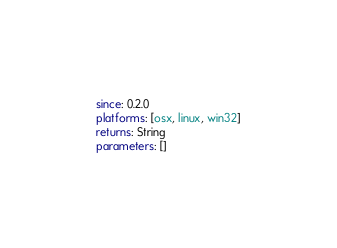<code> <loc_0><loc_0><loc_500><loc_500><_YAML_>since: 0.2.0
platforms: [osx, linux, win32]
returns: String
parameters: []
</code> 